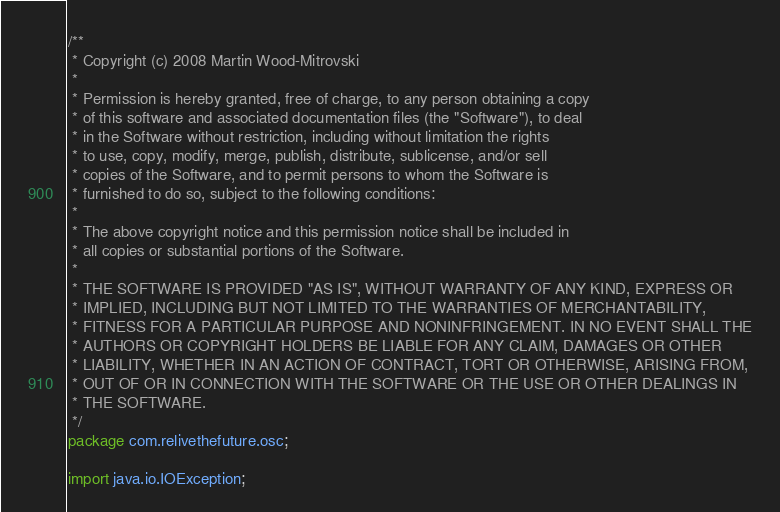<code> <loc_0><loc_0><loc_500><loc_500><_Java_>/**
 * Copyright (c) 2008 Martin Wood-Mitrovski
 * 
 * Permission is hereby granted, free of charge, to any person obtaining a copy
 * of this software and associated documentation files (the "Software"), to deal
 * in the Software without restriction, including without limitation the rights
 * to use, copy, modify, merge, publish, distribute, sublicense, and/or sell
 * copies of the Software, and to permit persons to whom the Software is
 * furnished to do so, subject to the following conditions:
 * 
 * The above copyright notice and this permission notice shall be included in
 * all copies or substantial portions of the Software.
 * 
 * THE SOFTWARE IS PROVIDED "AS IS", WITHOUT WARRANTY OF ANY KIND, EXPRESS OR
 * IMPLIED, INCLUDING BUT NOT LIMITED TO THE WARRANTIES OF MERCHANTABILITY,
 * FITNESS FOR A PARTICULAR PURPOSE AND NONINFRINGEMENT. IN NO EVENT SHALL THE
 * AUTHORS OR COPYRIGHT HOLDERS BE LIABLE FOR ANY CLAIM, DAMAGES OR OTHER
 * LIABILITY, WHETHER IN AN ACTION OF CONTRACT, TORT OR OTHERWISE, ARISING FROM,
 * OUT OF OR IN CONNECTION WITH THE SOFTWARE OR THE USE OR OTHER DEALINGS IN
 * THE SOFTWARE.
 */
package com.relivethefuture.osc;

import java.io.IOException;
</code> 